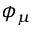Convert formula to latex. <formula><loc_0><loc_0><loc_500><loc_500>\phi _ { \mu }</formula> 